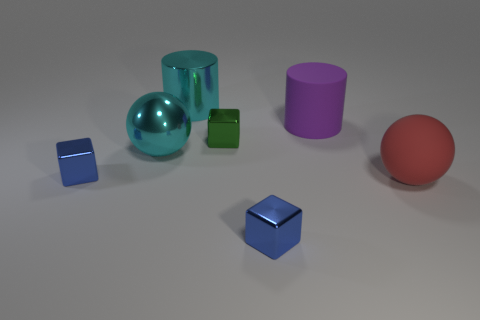Are there any objects on the right side of the big matte cylinder?
Your answer should be compact. Yes. Does the green thing have the same material as the big ball that is in front of the large metallic sphere?
Offer a very short reply. No. There is a tiny object that is on the left side of the big cyan metal sphere; is its shape the same as the small green metal object?
Offer a terse response. Yes. How many other large cylinders have the same material as the big cyan cylinder?
Ensure brevity in your answer.  0. How many objects are either shiny objects that are on the left side of the cyan metal ball or blocks?
Your answer should be very brief. 3. What is the size of the green shiny cube?
Provide a succinct answer. Small. The blue thing left of the tiny blue cube in front of the red rubber thing is made of what material?
Ensure brevity in your answer.  Metal. There is a cyan metal thing behind the metallic sphere; is it the same size as the small green metal object?
Make the answer very short. No. Is there a large shiny object of the same color as the big metallic cylinder?
Provide a succinct answer. Yes. What number of things are tiny metallic blocks on the right side of the green metal object or things in front of the purple rubber object?
Provide a short and direct response. 5. 